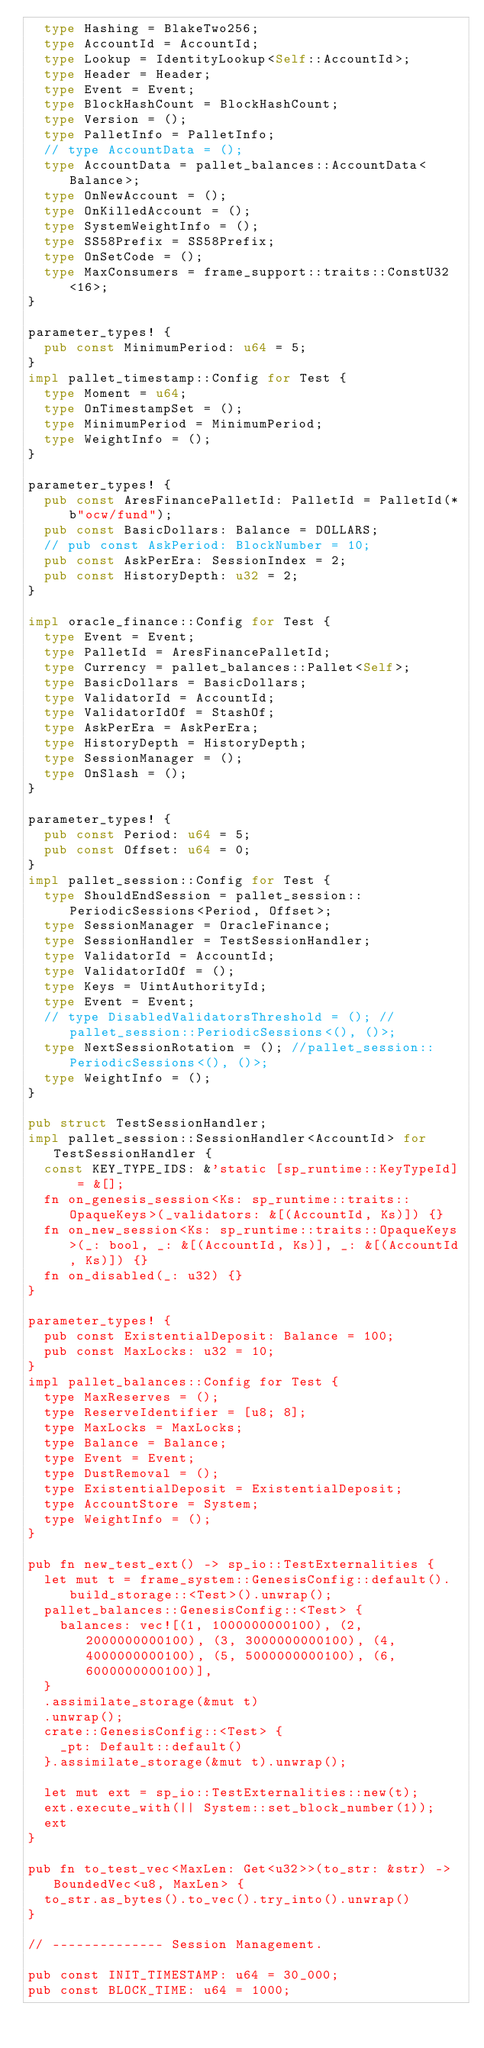<code> <loc_0><loc_0><loc_500><loc_500><_Rust_>	type Hashing = BlakeTwo256;
	type AccountId = AccountId;
	type Lookup = IdentityLookup<Self::AccountId>;
	type Header = Header;
	type Event = Event;
	type BlockHashCount = BlockHashCount;
	type Version = ();
	type PalletInfo = PalletInfo;
	// type AccountData = ();
	type AccountData = pallet_balances::AccountData<Balance>;
	type OnNewAccount = ();
	type OnKilledAccount = ();
	type SystemWeightInfo = ();
	type SS58Prefix = SS58Prefix;
	type OnSetCode = ();
	type MaxConsumers = frame_support::traits::ConstU32<16>;
}

parameter_types! {
	pub const MinimumPeriod: u64 = 5;
}
impl pallet_timestamp::Config for Test {
	type Moment = u64;
	type OnTimestampSet = ();
	type MinimumPeriod = MinimumPeriod;
	type WeightInfo = ();
}

parameter_types! {
	pub const AresFinancePalletId: PalletId = PalletId(*b"ocw/fund");
	pub const BasicDollars: Balance = DOLLARS;
	// pub const AskPeriod: BlockNumber = 10;
	pub const AskPerEra: SessionIndex = 2;
	pub const HistoryDepth: u32 = 2;
}

impl oracle_finance::Config for Test {
	type Event = Event;
	type PalletId = AresFinancePalletId;
	type Currency = pallet_balances::Pallet<Self>;
	type BasicDollars = BasicDollars;
	type ValidatorId = AccountId;
	type ValidatorIdOf = StashOf;
	type AskPerEra = AskPerEra;
	type HistoryDepth = HistoryDepth;
	type SessionManager = ();
	type OnSlash = ();
}

parameter_types! {
	pub const Period: u64 = 5;
	pub const Offset: u64 = 0;
}
impl pallet_session::Config for Test {
	type ShouldEndSession = pallet_session::PeriodicSessions<Period, Offset>;
	type SessionManager = OracleFinance;
	type SessionHandler = TestSessionHandler;
	type ValidatorId = AccountId;
	type ValidatorIdOf = ();
	type Keys = UintAuthorityId;
	type Event = Event;
	// type DisabledValidatorsThreshold = (); // pallet_session::PeriodicSessions<(), ()>;
	type NextSessionRotation = (); //pallet_session::PeriodicSessions<(), ()>;
	type WeightInfo = ();
}

pub struct TestSessionHandler;
impl pallet_session::SessionHandler<AccountId> for TestSessionHandler {
	const KEY_TYPE_IDS: &'static [sp_runtime::KeyTypeId] = &[];
	fn on_genesis_session<Ks: sp_runtime::traits::OpaqueKeys>(_validators: &[(AccountId, Ks)]) {}
	fn on_new_session<Ks: sp_runtime::traits::OpaqueKeys>(_: bool, _: &[(AccountId, Ks)], _: &[(AccountId, Ks)]) {}
	fn on_disabled(_: u32) {}
}

parameter_types! {
	pub const ExistentialDeposit: Balance = 100;
	pub const MaxLocks: u32 = 10;
}
impl pallet_balances::Config for Test {
	type MaxReserves = ();
	type ReserveIdentifier = [u8; 8];
	type MaxLocks = MaxLocks;
	type Balance = Balance;
	type Event = Event;
	type DustRemoval = ();
	type ExistentialDeposit = ExistentialDeposit;
	type AccountStore = System;
	type WeightInfo = ();
}

pub fn new_test_ext() -> sp_io::TestExternalities {
	let mut t = frame_system::GenesisConfig::default().build_storage::<Test>().unwrap();
	pallet_balances::GenesisConfig::<Test> {
		balances: vec![(1, 1000000000100), (2, 2000000000100), (3, 3000000000100), (4, 4000000000100), (5, 5000000000100), (6, 6000000000100)],
	}
	.assimilate_storage(&mut t)
	.unwrap();
	crate::GenesisConfig::<Test> {
		_pt: Default::default()
	}.assimilate_storage(&mut t).unwrap();
	
	let mut ext = sp_io::TestExternalities::new(t);
	ext.execute_with(|| System::set_block_number(1));
	ext
}

pub fn to_test_vec<MaxLen: Get<u32>>(to_str: &str) -> BoundedVec<u8, MaxLen> {
	to_str.as_bytes().to_vec().try_into().unwrap()
}

// -------------- Session Management.

pub const INIT_TIMESTAMP: u64 = 30_000;
pub const BLOCK_TIME: u64 = 1000;
</code> 